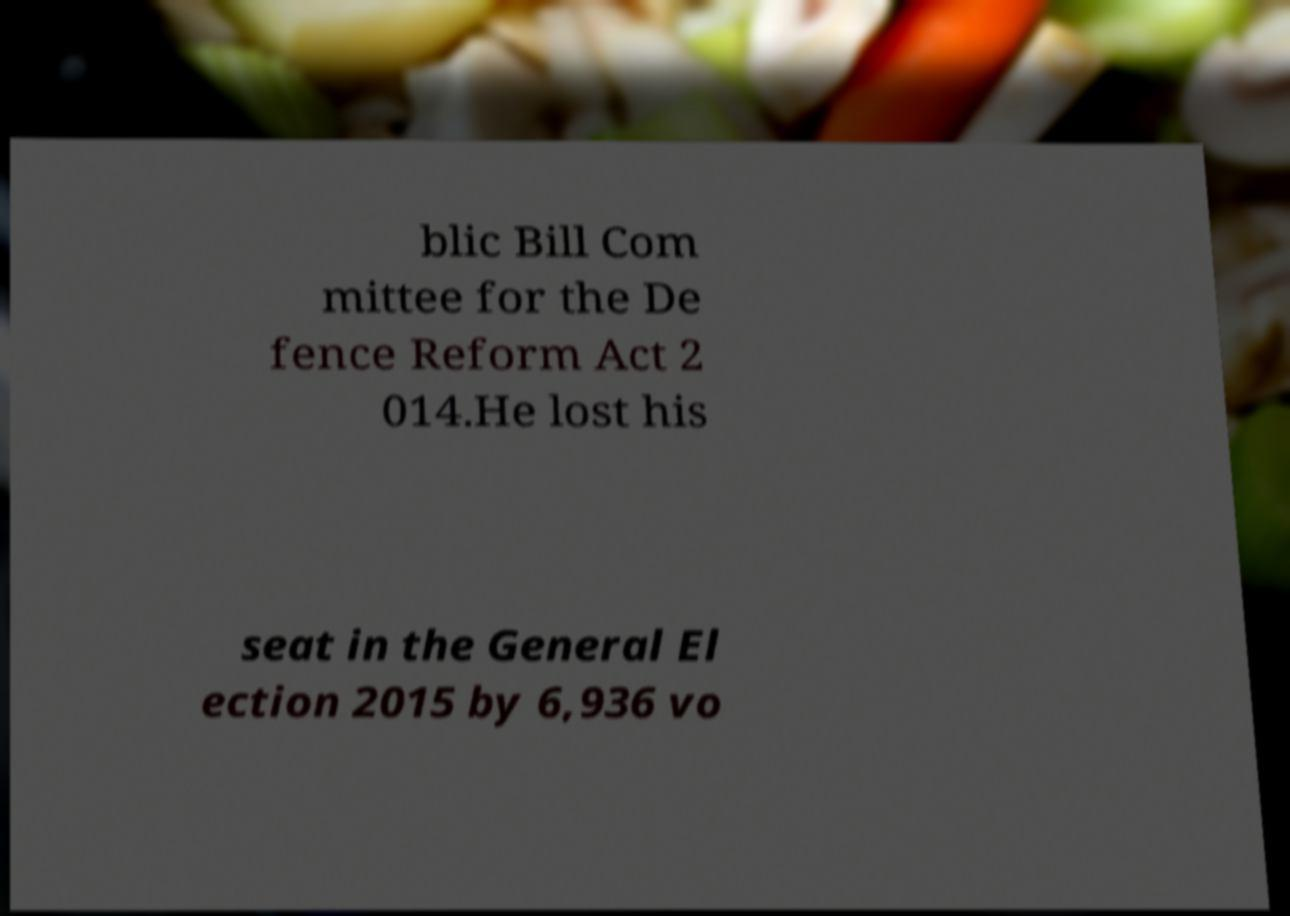What messages or text are displayed in this image? I need them in a readable, typed format. blic Bill Com mittee for the De fence Reform Act 2 014.He lost his seat in the General El ection 2015 by 6,936 vo 